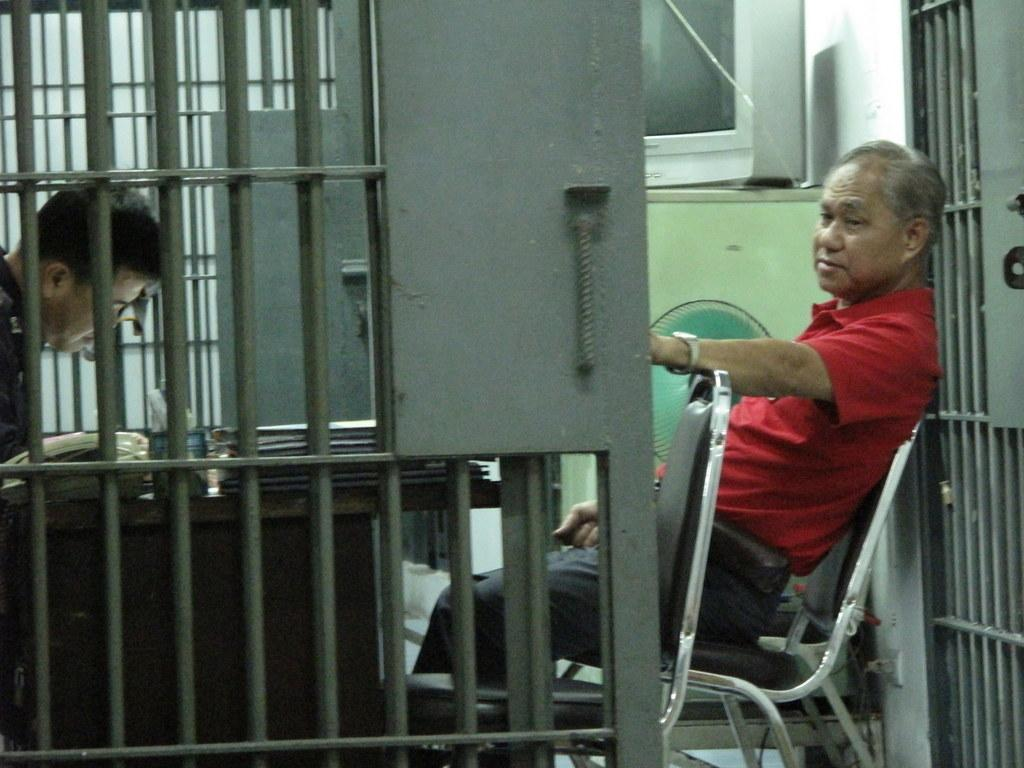How many people are in the image? There are two persons in the image. What are the persons doing in the image? The persons are sitting on chairs. What is present in the image besides the persons? There is a table in the image. What can be seen on the table? There are books on the table. What type of zebra is visible on the table in the image? There is no zebra present in the image; only two persons, chairs, and books are visible on the table. 